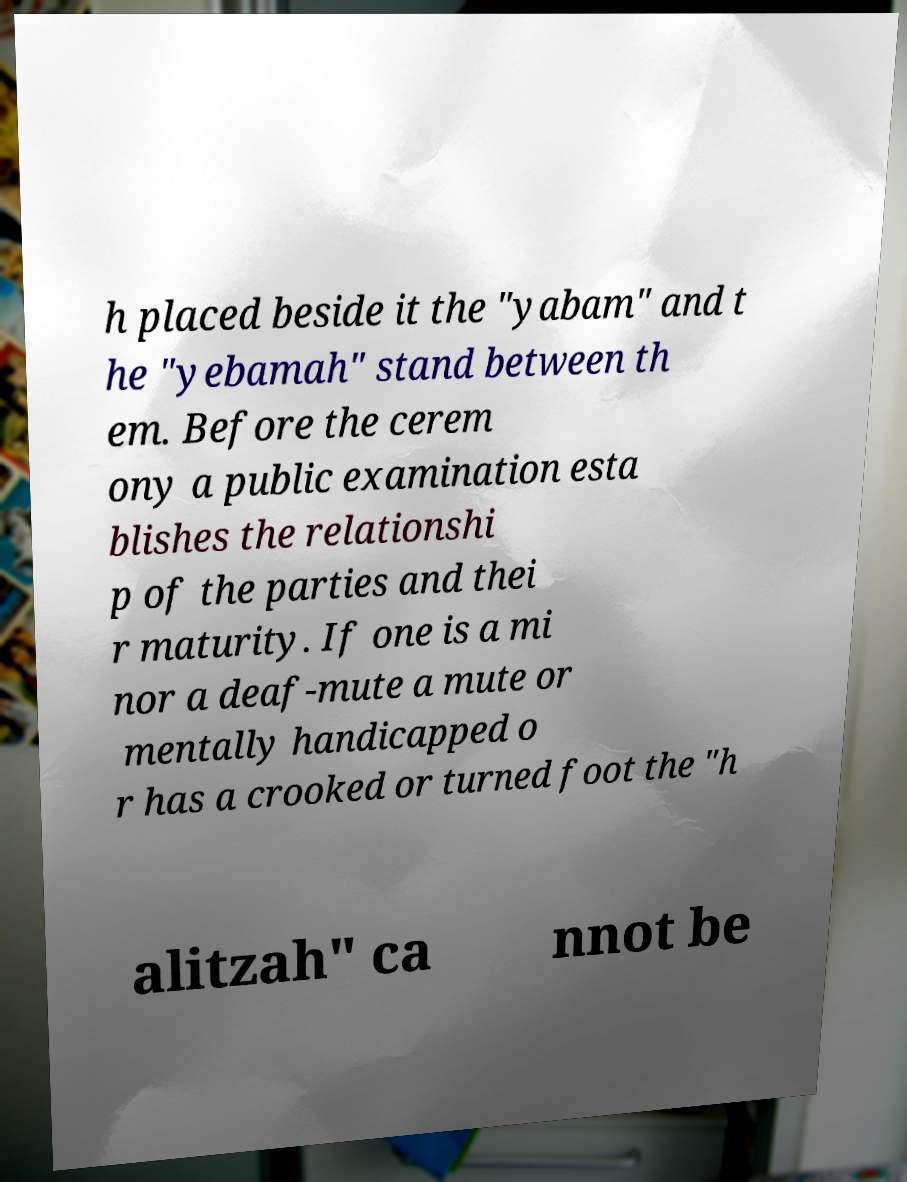Please identify and transcribe the text found in this image. h placed beside it the "yabam" and t he "yebamah" stand between th em. Before the cerem ony a public examination esta blishes the relationshi p of the parties and thei r maturity. If one is a mi nor a deaf-mute a mute or mentally handicapped o r has a crooked or turned foot the "h alitzah" ca nnot be 